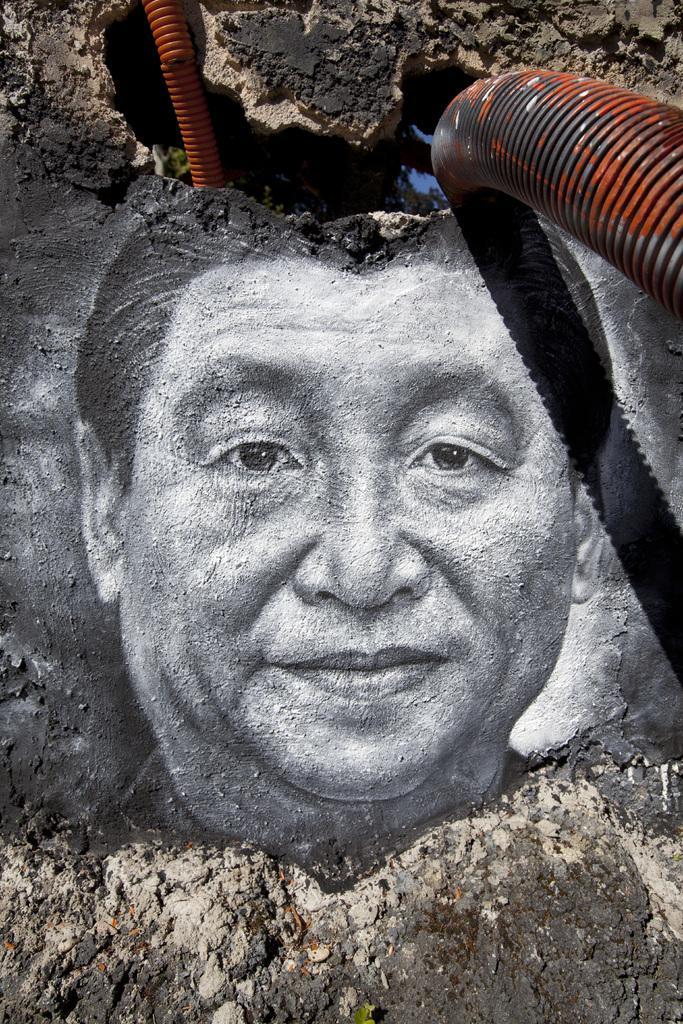How would you summarize this image in a sentence or two? In this image I can see person art which is in black and white color. We can see orange color pipes. 